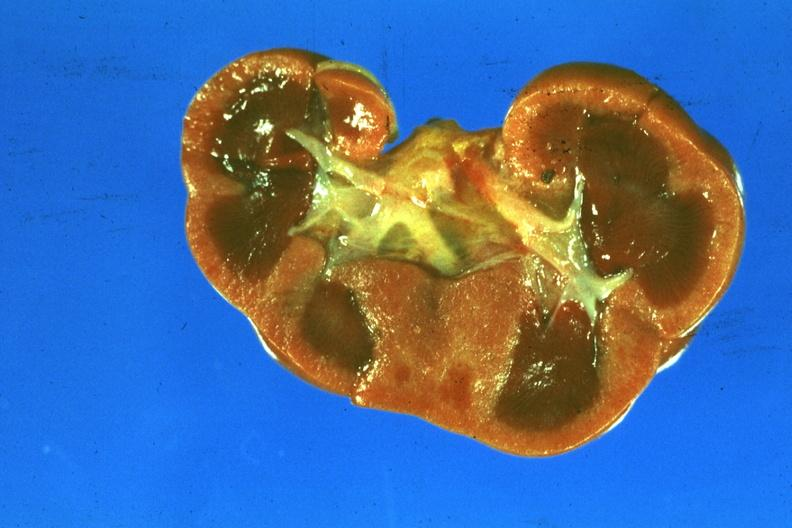s kidney present?
Answer the question using a single word or phrase. Yes 